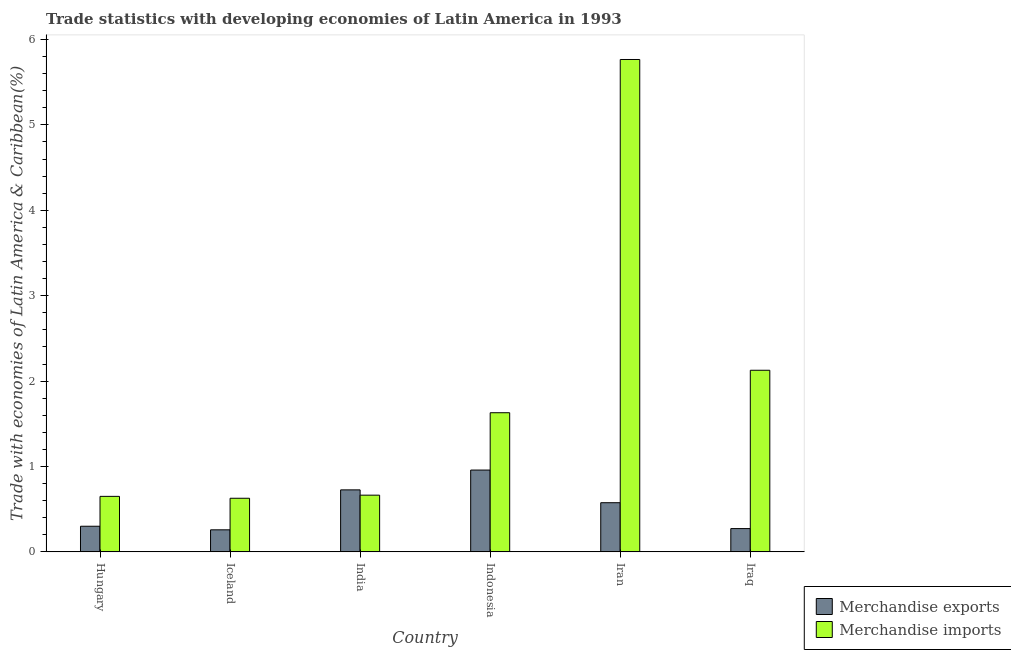How many different coloured bars are there?
Provide a succinct answer. 2. Are the number of bars on each tick of the X-axis equal?
Offer a terse response. Yes. How many bars are there on the 3rd tick from the left?
Provide a short and direct response. 2. What is the label of the 5th group of bars from the left?
Offer a very short reply. Iran. In how many cases, is the number of bars for a given country not equal to the number of legend labels?
Make the answer very short. 0. What is the merchandise imports in Iran?
Provide a short and direct response. 5.77. Across all countries, what is the maximum merchandise imports?
Your answer should be compact. 5.77. Across all countries, what is the minimum merchandise imports?
Give a very brief answer. 0.63. In which country was the merchandise imports maximum?
Offer a very short reply. Iran. In which country was the merchandise imports minimum?
Offer a terse response. Iceland. What is the total merchandise exports in the graph?
Your answer should be very brief. 3.09. What is the difference between the merchandise exports in Indonesia and that in Iraq?
Your answer should be compact. 0.69. What is the difference between the merchandise imports in Iran and the merchandise exports in India?
Your answer should be very brief. 5.04. What is the average merchandise exports per country?
Ensure brevity in your answer.  0.52. What is the difference between the merchandise exports and merchandise imports in India?
Your response must be concise. 0.06. In how many countries, is the merchandise imports greater than 2.2 %?
Your response must be concise. 1. What is the ratio of the merchandise imports in Iran to that in Iraq?
Your answer should be very brief. 2.71. Is the difference between the merchandise imports in India and Iraq greater than the difference between the merchandise exports in India and Iraq?
Keep it short and to the point. No. What is the difference between the highest and the second highest merchandise exports?
Offer a terse response. 0.23. What is the difference between the highest and the lowest merchandise imports?
Your response must be concise. 5.14. How many bars are there?
Ensure brevity in your answer.  12. Does the graph contain grids?
Offer a terse response. No. How many legend labels are there?
Keep it short and to the point. 2. What is the title of the graph?
Your answer should be very brief. Trade statistics with developing economies of Latin America in 1993. Does "Highest 20% of population" appear as one of the legend labels in the graph?
Your response must be concise. No. What is the label or title of the X-axis?
Keep it short and to the point. Country. What is the label or title of the Y-axis?
Give a very brief answer. Trade with economies of Latin America & Caribbean(%). What is the Trade with economies of Latin America & Caribbean(%) in Merchandise exports in Hungary?
Provide a short and direct response. 0.3. What is the Trade with economies of Latin America & Caribbean(%) of Merchandise imports in Hungary?
Keep it short and to the point. 0.65. What is the Trade with economies of Latin America & Caribbean(%) in Merchandise exports in Iceland?
Give a very brief answer. 0.26. What is the Trade with economies of Latin America & Caribbean(%) of Merchandise imports in Iceland?
Provide a short and direct response. 0.63. What is the Trade with economies of Latin America & Caribbean(%) in Merchandise exports in India?
Provide a succinct answer. 0.73. What is the Trade with economies of Latin America & Caribbean(%) of Merchandise imports in India?
Make the answer very short. 0.66. What is the Trade with economies of Latin America & Caribbean(%) in Merchandise exports in Indonesia?
Offer a very short reply. 0.96. What is the Trade with economies of Latin America & Caribbean(%) in Merchandise imports in Indonesia?
Your answer should be very brief. 1.63. What is the Trade with economies of Latin America & Caribbean(%) of Merchandise exports in Iran?
Offer a very short reply. 0.58. What is the Trade with economies of Latin America & Caribbean(%) in Merchandise imports in Iran?
Offer a terse response. 5.77. What is the Trade with economies of Latin America & Caribbean(%) in Merchandise exports in Iraq?
Offer a very short reply. 0.27. What is the Trade with economies of Latin America & Caribbean(%) of Merchandise imports in Iraq?
Give a very brief answer. 2.13. Across all countries, what is the maximum Trade with economies of Latin America & Caribbean(%) of Merchandise exports?
Give a very brief answer. 0.96. Across all countries, what is the maximum Trade with economies of Latin America & Caribbean(%) of Merchandise imports?
Your answer should be compact. 5.77. Across all countries, what is the minimum Trade with economies of Latin America & Caribbean(%) in Merchandise exports?
Your answer should be very brief. 0.26. Across all countries, what is the minimum Trade with economies of Latin America & Caribbean(%) in Merchandise imports?
Ensure brevity in your answer.  0.63. What is the total Trade with economies of Latin America & Caribbean(%) of Merchandise exports in the graph?
Your answer should be very brief. 3.09. What is the total Trade with economies of Latin America & Caribbean(%) of Merchandise imports in the graph?
Keep it short and to the point. 11.46. What is the difference between the Trade with economies of Latin America & Caribbean(%) in Merchandise exports in Hungary and that in Iceland?
Your answer should be compact. 0.04. What is the difference between the Trade with economies of Latin America & Caribbean(%) in Merchandise imports in Hungary and that in Iceland?
Your answer should be compact. 0.02. What is the difference between the Trade with economies of Latin America & Caribbean(%) in Merchandise exports in Hungary and that in India?
Ensure brevity in your answer.  -0.43. What is the difference between the Trade with economies of Latin America & Caribbean(%) in Merchandise imports in Hungary and that in India?
Provide a succinct answer. -0.01. What is the difference between the Trade with economies of Latin America & Caribbean(%) in Merchandise exports in Hungary and that in Indonesia?
Provide a succinct answer. -0.66. What is the difference between the Trade with economies of Latin America & Caribbean(%) in Merchandise imports in Hungary and that in Indonesia?
Your answer should be compact. -0.98. What is the difference between the Trade with economies of Latin America & Caribbean(%) in Merchandise exports in Hungary and that in Iran?
Give a very brief answer. -0.28. What is the difference between the Trade with economies of Latin America & Caribbean(%) in Merchandise imports in Hungary and that in Iran?
Your answer should be compact. -5.12. What is the difference between the Trade with economies of Latin America & Caribbean(%) of Merchandise exports in Hungary and that in Iraq?
Keep it short and to the point. 0.03. What is the difference between the Trade with economies of Latin America & Caribbean(%) in Merchandise imports in Hungary and that in Iraq?
Your response must be concise. -1.48. What is the difference between the Trade with economies of Latin America & Caribbean(%) of Merchandise exports in Iceland and that in India?
Your response must be concise. -0.47. What is the difference between the Trade with economies of Latin America & Caribbean(%) in Merchandise imports in Iceland and that in India?
Offer a very short reply. -0.04. What is the difference between the Trade with economies of Latin America & Caribbean(%) of Merchandise exports in Iceland and that in Indonesia?
Your answer should be compact. -0.7. What is the difference between the Trade with economies of Latin America & Caribbean(%) of Merchandise imports in Iceland and that in Indonesia?
Offer a terse response. -1. What is the difference between the Trade with economies of Latin America & Caribbean(%) of Merchandise exports in Iceland and that in Iran?
Ensure brevity in your answer.  -0.32. What is the difference between the Trade with economies of Latin America & Caribbean(%) in Merchandise imports in Iceland and that in Iran?
Keep it short and to the point. -5.14. What is the difference between the Trade with economies of Latin America & Caribbean(%) of Merchandise exports in Iceland and that in Iraq?
Make the answer very short. -0.01. What is the difference between the Trade with economies of Latin America & Caribbean(%) in Merchandise imports in Iceland and that in Iraq?
Make the answer very short. -1.5. What is the difference between the Trade with economies of Latin America & Caribbean(%) of Merchandise exports in India and that in Indonesia?
Keep it short and to the point. -0.23. What is the difference between the Trade with economies of Latin America & Caribbean(%) of Merchandise imports in India and that in Indonesia?
Provide a succinct answer. -0.97. What is the difference between the Trade with economies of Latin America & Caribbean(%) in Merchandise exports in India and that in Iran?
Provide a short and direct response. 0.15. What is the difference between the Trade with economies of Latin America & Caribbean(%) in Merchandise imports in India and that in Iran?
Your answer should be very brief. -5.1. What is the difference between the Trade with economies of Latin America & Caribbean(%) of Merchandise exports in India and that in Iraq?
Give a very brief answer. 0.45. What is the difference between the Trade with economies of Latin America & Caribbean(%) in Merchandise imports in India and that in Iraq?
Your answer should be compact. -1.46. What is the difference between the Trade with economies of Latin America & Caribbean(%) of Merchandise exports in Indonesia and that in Iran?
Your answer should be compact. 0.38. What is the difference between the Trade with economies of Latin America & Caribbean(%) of Merchandise imports in Indonesia and that in Iran?
Your answer should be very brief. -4.14. What is the difference between the Trade with economies of Latin America & Caribbean(%) in Merchandise exports in Indonesia and that in Iraq?
Keep it short and to the point. 0.69. What is the difference between the Trade with economies of Latin America & Caribbean(%) of Merchandise imports in Indonesia and that in Iraq?
Provide a short and direct response. -0.5. What is the difference between the Trade with economies of Latin America & Caribbean(%) of Merchandise exports in Iran and that in Iraq?
Offer a very short reply. 0.3. What is the difference between the Trade with economies of Latin America & Caribbean(%) of Merchandise imports in Iran and that in Iraq?
Ensure brevity in your answer.  3.64. What is the difference between the Trade with economies of Latin America & Caribbean(%) in Merchandise exports in Hungary and the Trade with economies of Latin America & Caribbean(%) in Merchandise imports in Iceland?
Give a very brief answer. -0.33. What is the difference between the Trade with economies of Latin America & Caribbean(%) in Merchandise exports in Hungary and the Trade with economies of Latin America & Caribbean(%) in Merchandise imports in India?
Provide a short and direct response. -0.36. What is the difference between the Trade with economies of Latin America & Caribbean(%) of Merchandise exports in Hungary and the Trade with economies of Latin America & Caribbean(%) of Merchandise imports in Indonesia?
Offer a very short reply. -1.33. What is the difference between the Trade with economies of Latin America & Caribbean(%) in Merchandise exports in Hungary and the Trade with economies of Latin America & Caribbean(%) in Merchandise imports in Iran?
Give a very brief answer. -5.47. What is the difference between the Trade with economies of Latin America & Caribbean(%) of Merchandise exports in Hungary and the Trade with economies of Latin America & Caribbean(%) of Merchandise imports in Iraq?
Keep it short and to the point. -1.83. What is the difference between the Trade with economies of Latin America & Caribbean(%) of Merchandise exports in Iceland and the Trade with economies of Latin America & Caribbean(%) of Merchandise imports in India?
Provide a succinct answer. -0.41. What is the difference between the Trade with economies of Latin America & Caribbean(%) of Merchandise exports in Iceland and the Trade with economies of Latin America & Caribbean(%) of Merchandise imports in Indonesia?
Ensure brevity in your answer.  -1.37. What is the difference between the Trade with economies of Latin America & Caribbean(%) in Merchandise exports in Iceland and the Trade with economies of Latin America & Caribbean(%) in Merchandise imports in Iran?
Provide a succinct answer. -5.51. What is the difference between the Trade with economies of Latin America & Caribbean(%) in Merchandise exports in Iceland and the Trade with economies of Latin America & Caribbean(%) in Merchandise imports in Iraq?
Offer a very short reply. -1.87. What is the difference between the Trade with economies of Latin America & Caribbean(%) of Merchandise exports in India and the Trade with economies of Latin America & Caribbean(%) of Merchandise imports in Indonesia?
Your answer should be compact. -0.9. What is the difference between the Trade with economies of Latin America & Caribbean(%) of Merchandise exports in India and the Trade with economies of Latin America & Caribbean(%) of Merchandise imports in Iran?
Ensure brevity in your answer.  -5.04. What is the difference between the Trade with economies of Latin America & Caribbean(%) in Merchandise exports in India and the Trade with economies of Latin America & Caribbean(%) in Merchandise imports in Iraq?
Keep it short and to the point. -1.4. What is the difference between the Trade with economies of Latin America & Caribbean(%) in Merchandise exports in Indonesia and the Trade with economies of Latin America & Caribbean(%) in Merchandise imports in Iran?
Keep it short and to the point. -4.81. What is the difference between the Trade with economies of Latin America & Caribbean(%) in Merchandise exports in Indonesia and the Trade with economies of Latin America & Caribbean(%) in Merchandise imports in Iraq?
Your answer should be compact. -1.17. What is the difference between the Trade with economies of Latin America & Caribbean(%) of Merchandise exports in Iran and the Trade with economies of Latin America & Caribbean(%) of Merchandise imports in Iraq?
Offer a terse response. -1.55. What is the average Trade with economies of Latin America & Caribbean(%) in Merchandise exports per country?
Offer a very short reply. 0.52. What is the average Trade with economies of Latin America & Caribbean(%) in Merchandise imports per country?
Provide a succinct answer. 1.91. What is the difference between the Trade with economies of Latin America & Caribbean(%) of Merchandise exports and Trade with economies of Latin America & Caribbean(%) of Merchandise imports in Hungary?
Offer a very short reply. -0.35. What is the difference between the Trade with economies of Latin America & Caribbean(%) of Merchandise exports and Trade with economies of Latin America & Caribbean(%) of Merchandise imports in Iceland?
Your response must be concise. -0.37. What is the difference between the Trade with economies of Latin America & Caribbean(%) of Merchandise exports and Trade with economies of Latin America & Caribbean(%) of Merchandise imports in India?
Your answer should be very brief. 0.06. What is the difference between the Trade with economies of Latin America & Caribbean(%) in Merchandise exports and Trade with economies of Latin America & Caribbean(%) in Merchandise imports in Indonesia?
Provide a succinct answer. -0.67. What is the difference between the Trade with economies of Latin America & Caribbean(%) in Merchandise exports and Trade with economies of Latin America & Caribbean(%) in Merchandise imports in Iran?
Give a very brief answer. -5.19. What is the difference between the Trade with economies of Latin America & Caribbean(%) of Merchandise exports and Trade with economies of Latin America & Caribbean(%) of Merchandise imports in Iraq?
Make the answer very short. -1.85. What is the ratio of the Trade with economies of Latin America & Caribbean(%) in Merchandise exports in Hungary to that in Iceland?
Your answer should be compact. 1.16. What is the ratio of the Trade with economies of Latin America & Caribbean(%) of Merchandise imports in Hungary to that in Iceland?
Your answer should be compact. 1.04. What is the ratio of the Trade with economies of Latin America & Caribbean(%) of Merchandise exports in Hungary to that in India?
Make the answer very short. 0.41. What is the ratio of the Trade with economies of Latin America & Caribbean(%) of Merchandise imports in Hungary to that in India?
Offer a very short reply. 0.98. What is the ratio of the Trade with economies of Latin America & Caribbean(%) in Merchandise exports in Hungary to that in Indonesia?
Offer a very short reply. 0.31. What is the ratio of the Trade with economies of Latin America & Caribbean(%) in Merchandise imports in Hungary to that in Indonesia?
Offer a very short reply. 0.4. What is the ratio of the Trade with economies of Latin America & Caribbean(%) of Merchandise exports in Hungary to that in Iran?
Your answer should be compact. 0.52. What is the ratio of the Trade with economies of Latin America & Caribbean(%) of Merchandise imports in Hungary to that in Iran?
Provide a short and direct response. 0.11. What is the ratio of the Trade with economies of Latin America & Caribbean(%) of Merchandise exports in Hungary to that in Iraq?
Make the answer very short. 1.1. What is the ratio of the Trade with economies of Latin America & Caribbean(%) in Merchandise imports in Hungary to that in Iraq?
Your answer should be compact. 0.31. What is the ratio of the Trade with economies of Latin America & Caribbean(%) in Merchandise exports in Iceland to that in India?
Offer a very short reply. 0.36. What is the ratio of the Trade with economies of Latin America & Caribbean(%) of Merchandise imports in Iceland to that in India?
Your answer should be very brief. 0.95. What is the ratio of the Trade with economies of Latin America & Caribbean(%) of Merchandise exports in Iceland to that in Indonesia?
Offer a very short reply. 0.27. What is the ratio of the Trade with economies of Latin America & Caribbean(%) in Merchandise imports in Iceland to that in Indonesia?
Make the answer very short. 0.39. What is the ratio of the Trade with economies of Latin America & Caribbean(%) in Merchandise exports in Iceland to that in Iran?
Provide a short and direct response. 0.45. What is the ratio of the Trade with economies of Latin America & Caribbean(%) of Merchandise imports in Iceland to that in Iran?
Offer a terse response. 0.11. What is the ratio of the Trade with economies of Latin America & Caribbean(%) in Merchandise exports in Iceland to that in Iraq?
Offer a very short reply. 0.95. What is the ratio of the Trade with economies of Latin America & Caribbean(%) of Merchandise imports in Iceland to that in Iraq?
Offer a very short reply. 0.3. What is the ratio of the Trade with economies of Latin America & Caribbean(%) of Merchandise exports in India to that in Indonesia?
Provide a succinct answer. 0.76. What is the ratio of the Trade with economies of Latin America & Caribbean(%) of Merchandise imports in India to that in Indonesia?
Provide a succinct answer. 0.41. What is the ratio of the Trade with economies of Latin America & Caribbean(%) of Merchandise exports in India to that in Iran?
Offer a terse response. 1.26. What is the ratio of the Trade with economies of Latin America & Caribbean(%) of Merchandise imports in India to that in Iran?
Your answer should be compact. 0.12. What is the ratio of the Trade with economies of Latin America & Caribbean(%) of Merchandise exports in India to that in Iraq?
Offer a terse response. 2.66. What is the ratio of the Trade with economies of Latin America & Caribbean(%) of Merchandise imports in India to that in Iraq?
Keep it short and to the point. 0.31. What is the ratio of the Trade with economies of Latin America & Caribbean(%) of Merchandise exports in Indonesia to that in Iran?
Give a very brief answer. 1.66. What is the ratio of the Trade with economies of Latin America & Caribbean(%) of Merchandise imports in Indonesia to that in Iran?
Provide a short and direct response. 0.28. What is the ratio of the Trade with economies of Latin America & Caribbean(%) of Merchandise exports in Indonesia to that in Iraq?
Make the answer very short. 3.51. What is the ratio of the Trade with economies of Latin America & Caribbean(%) of Merchandise imports in Indonesia to that in Iraq?
Offer a terse response. 0.77. What is the ratio of the Trade with economies of Latin America & Caribbean(%) in Merchandise exports in Iran to that in Iraq?
Your answer should be compact. 2.11. What is the ratio of the Trade with economies of Latin America & Caribbean(%) in Merchandise imports in Iran to that in Iraq?
Keep it short and to the point. 2.71. What is the difference between the highest and the second highest Trade with economies of Latin America & Caribbean(%) in Merchandise exports?
Your answer should be very brief. 0.23. What is the difference between the highest and the second highest Trade with economies of Latin America & Caribbean(%) of Merchandise imports?
Provide a succinct answer. 3.64. What is the difference between the highest and the lowest Trade with economies of Latin America & Caribbean(%) of Merchandise exports?
Your response must be concise. 0.7. What is the difference between the highest and the lowest Trade with economies of Latin America & Caribbean(%) in Merchandise imports?
Your response must be concise. 5.14. 